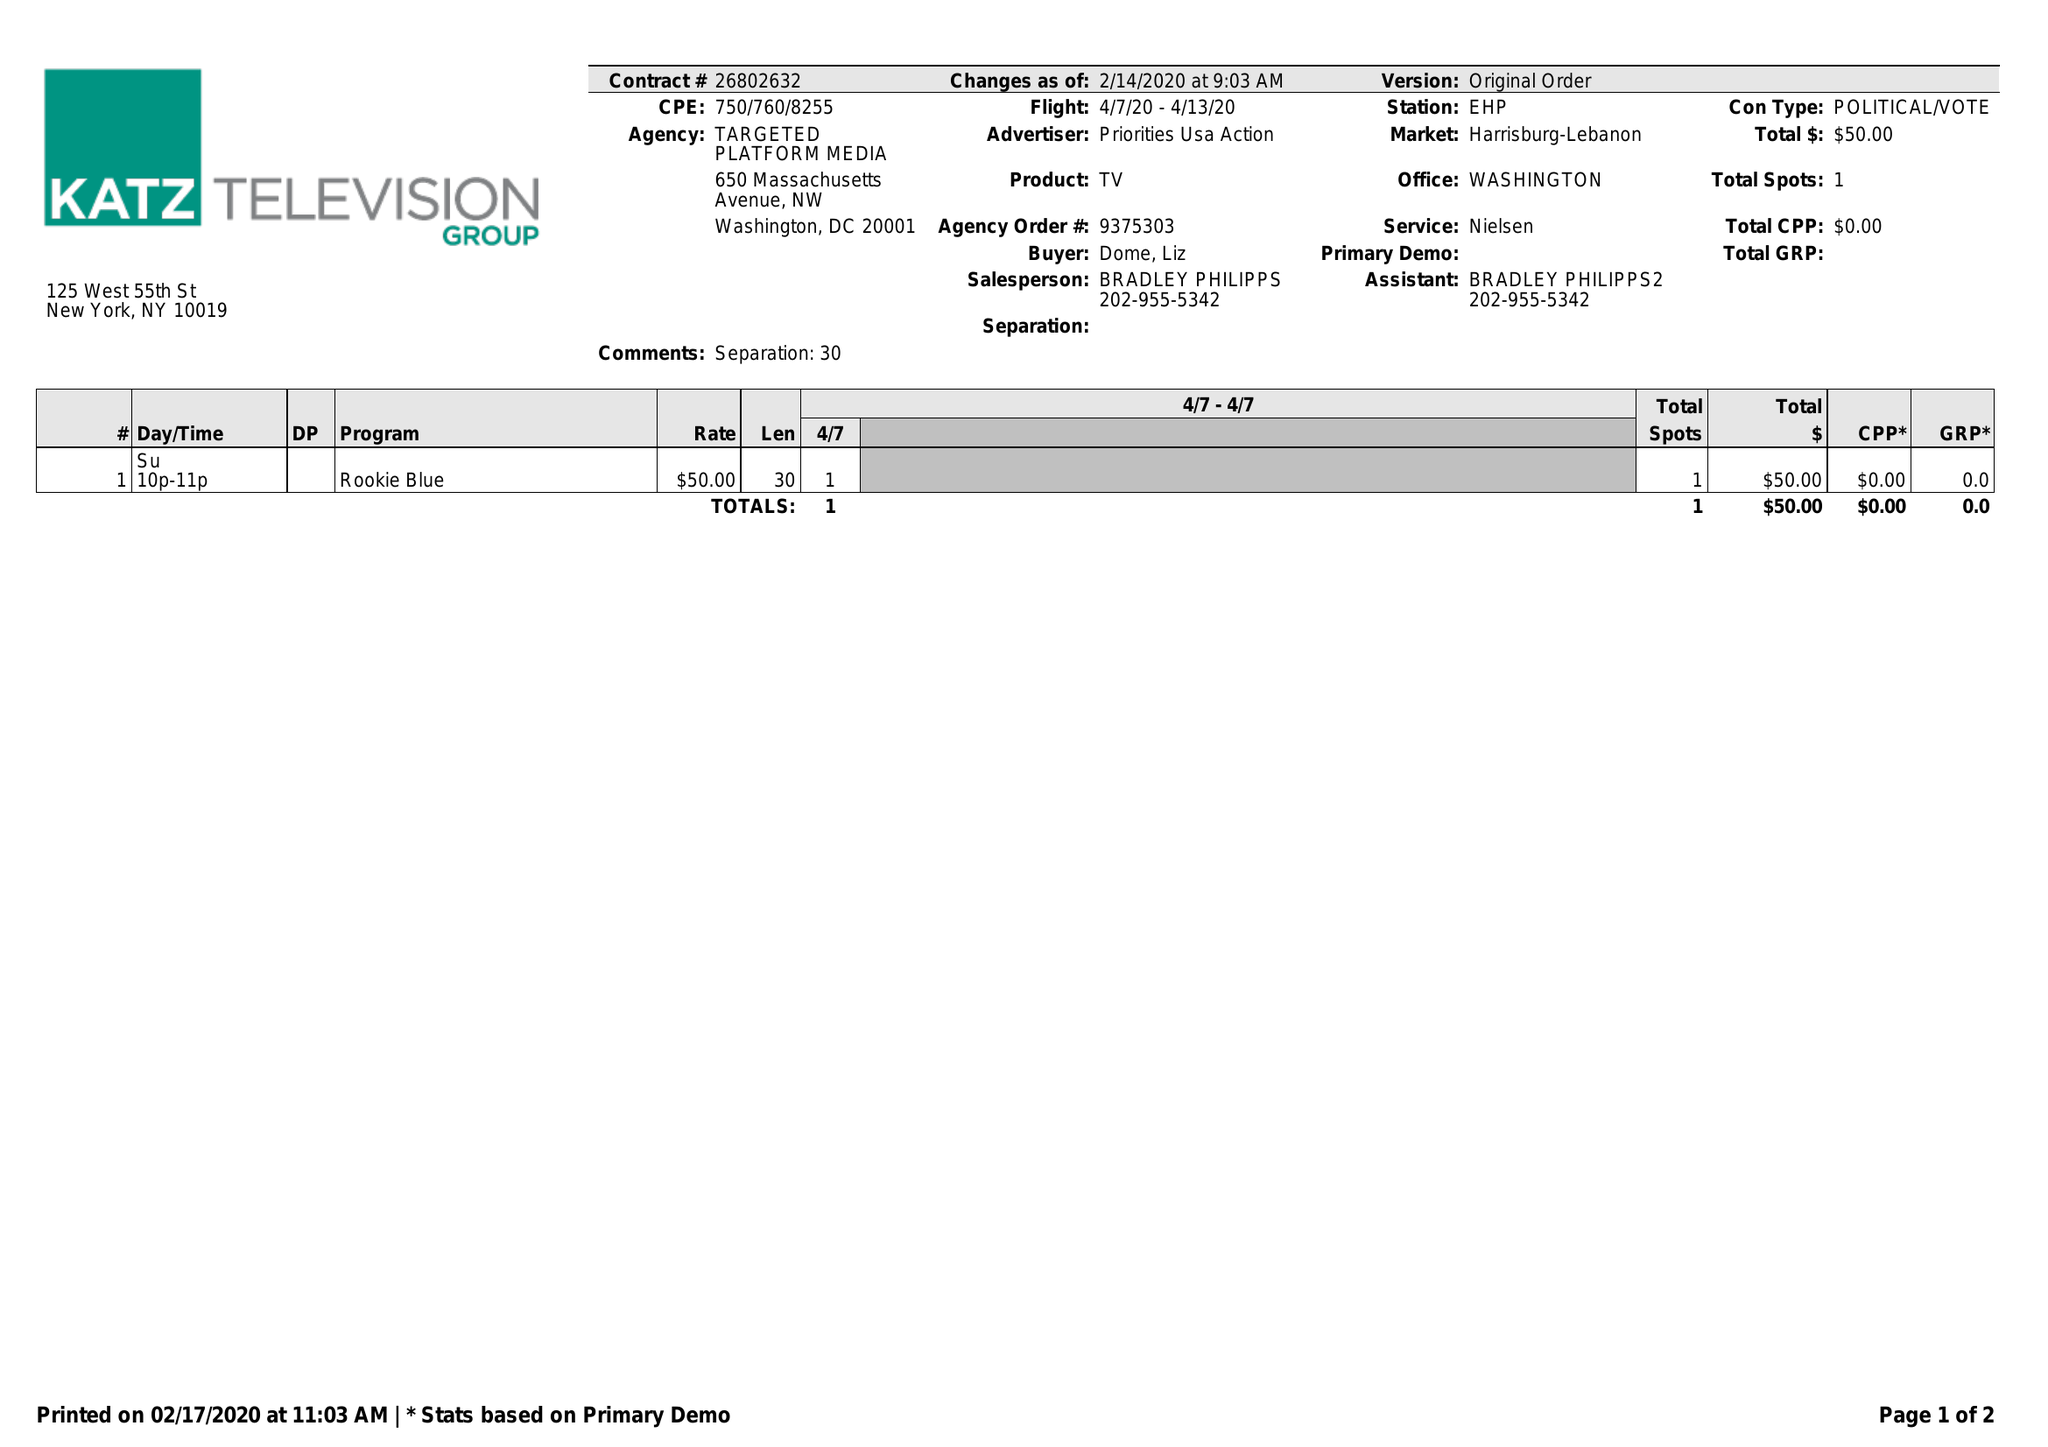What is the value for the advertiser?
Answer the question using a single word or phrase. PRIORITIES USA ACTION 